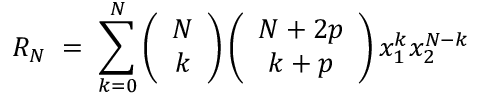<formula> <loc_0><loc_0><loc_500><loc_500>R _ { N } \, = \, \sum _ { k = 0 } ^ { N } \left ( \begin{array} { c } { N } \\ { k } \end{array} \right ) \left ( \begin{array} { c } { N + 2 p } \\ { k + p } \end{array} \right ) x _ { 1 } ^ { k } x _ { 2 } ^ { N - k }</formula> 